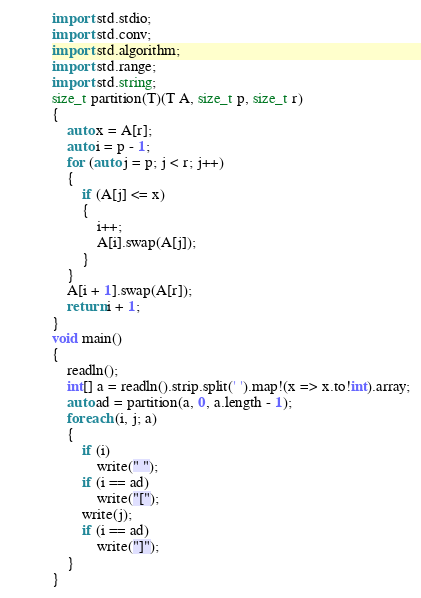Convert code to text. <code><loc_0><loc_0><loc_500><loc_500><_D_>import std.stdio;
import std.conv;
import std.algorithm;
import std.range;
import std.string;
size_t partition(T)(T A, size_t p, size_t r)
{
    auto x = A[r];
    auto i = p - 1;
    for (auto j = p; j < r; j++)
    {
        if (A[j] <= x)
        {
            i++;
            A[i].swap(A[j]);
        }
    }
    A[i + 1].swap(A[r]);
    return i + 1;
}
void main()
{
    readln();
    int[] a = readln().strip.split(' ').map!(x => x.to!int).array;
    auto ad = partition(a, 0, a.length - 1);
    foreach (i, j; a)
    {
        if (i)
            write(" ");
        if (i == ad)
            write("[");
        write(j);
        if (i == ad)
            write("]");
    }
}

</code> 